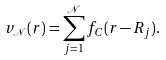Convert formula to latex. <formula><loc_0><loc_0><loc_500><loc_500>v _ { \mathcal { N } } ( { r } ) = \sum ^ { \mathcal { N } } _ { j = 1 } f _ { C } ( { r } - { R } _ { j } ) .</formula> 